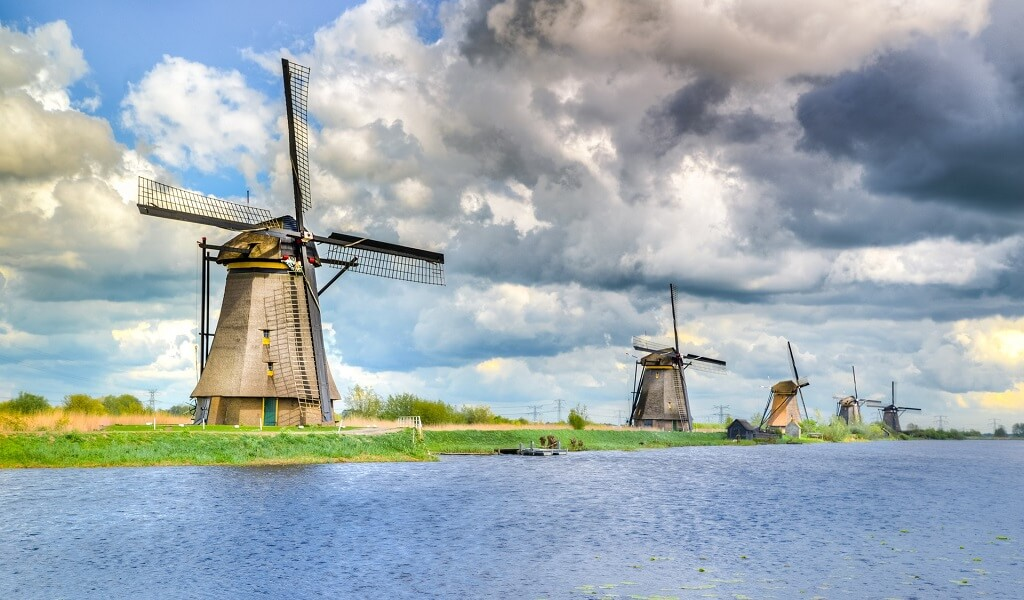Imagine if these windmills were part of a fantasy world. What would their purpose be? In a magical realm, these windmills could be the grand towers of a guild of wind magi, each skilled in harnessing the winds for various mystical purposes. The sails would be enchanted to capture and store wind energy, which the magi could then use to control weather patterns, power flying ships, and even communicate over vast distances. The canal itself might be a channel for a crystal-clear, enchanted river that glows under the moonlight, providing both a source of magical energy and a traversable waterway teeming with mythical creatures. These windmills would be at the heart of this fantastical world, standing as beacons of harmony between nature and magic. Could these windmills play a role in a conflict within this fantasy setting? Absolutely! In the heat of an epic conflict, the windmills could become fortresses for the defenders of the realm. The magical properties of the windmills could be ramped up to shield the region from invaders, with ethereal barriers of wind and energy protecting the land. The sails might convert into massive blades, serving as deterrents against flying beasts or dark forces attempting an aerial assault. The canals would transform into strategic moats filled with enchanted waters that could repel any dark magic thrown against the windmills. Each windmill would be a bastion, combining ancient engineering with sorcery to safeguard the heartland. Guardians and scholars of the wind magi guild would band together to maintain and operate these magical defenses, ensuring the region’s safety and sovereignty. 